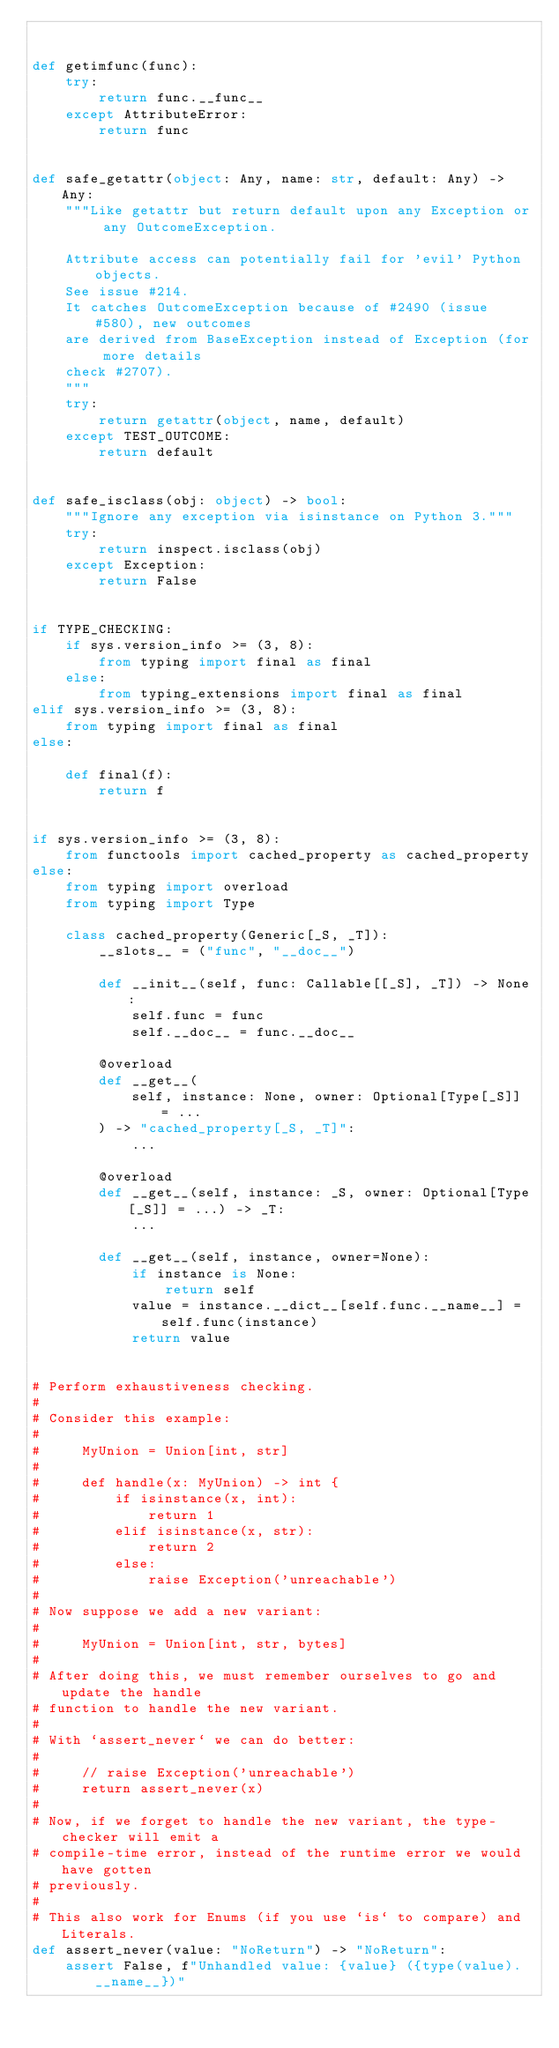Convert code to text. <code><loc_0><loc_0><loc_500><loc_500><_Python_>

def getimfunc(func):
    try:
        return func.__func__
    except AttributeError:
        return func


def safe_getattr(object: Any, name: str, default: Any) -> Any:
    """Like getattr but return default upon any Exception or any OutcomeException.

    Attribute access can potentially fail for 'evil' Python objects.
    See issue #214.
    It catches OutcomeException because of #2490 (issue #580), new outcomes
    are derived from BaseException instead of Exception (for more details
    check #2707).
    """
    try:
        return getattr(object, name, default)
    except TEST_OUTCOME:
        return default


def safe_isclass(obj: object) -> bool:
    """Ignore any exception via isinstance on Python 3."""
    try:
        return inspect.isclass(obj)
    except Exception:
        return False


if TYPE_CHECKING:
    if sys.version_info >= (3, 8):
        from typing import final as final
    else:
        from typing_extensions import final as final
elif sys.version_info >= (3, 8):
    from typing import final as final
else:

    def final(f):
        return f


if sys.version_info >= (3, 8):
    from functools import cached_property as cached_property
else:
    from typing import overload
    from typing import Type

    class cached_property(Generic[_S, _T]):
        __slots__ = ("func", "__doc__")

        def __init__(self, func: Callable[[_S], _T]) -> None:
            self.func = func
            self.__doc__ = func.__doc__

        @overload
        def __get__(
            self, instance: None, owner: Optional[Type[_S]] = ...
        ) -> "cached_property[_S, _T]":
            ...

        @overload
        def __get__(self, instance: _S, owner: Optional[Type[_S]] = ...) -> _T:
            ...

        def __get__(self, instance, owner=None):
            if instance is None:
                return self
            value = instance.__dict__[self.func.__name__] = self.func(instance)
            return value


# Perform exhaustiveness checking.
#
# Consider this example:
#
#     MyUnion = Union[int, str]
#
#     def handle(x: MyUnion) -> int {
#         if isinstance(x, int):
#             return 1
#         elif isinstance(x, str):
#             return 2
#         else:
#             raise Exception('unreachable')
#
# Now suppose we add a new variant:
#
#     MyUnion = Union[int, str, bytes]
#
# After doing this, we must remember ourselves to go and update the handle
# function to handle the new variant.
#
# With `assert_never` we can do better:
#
#     // raise Exception('unreachable')
#     return assert_never(x)
#
# Now, if we forget to handle the new variant, the type-checker will emit a
# compile-time error, instead of the runtime error we would have gotten
# previously.
#
# This also work for Enums (if you use `is` to compare) and Literals.
def assert_never(value: "NoReturn") -> "NoReturn":
    assert False, f"Unhandled value: {value} ({type(value).__name__})"
</code> 